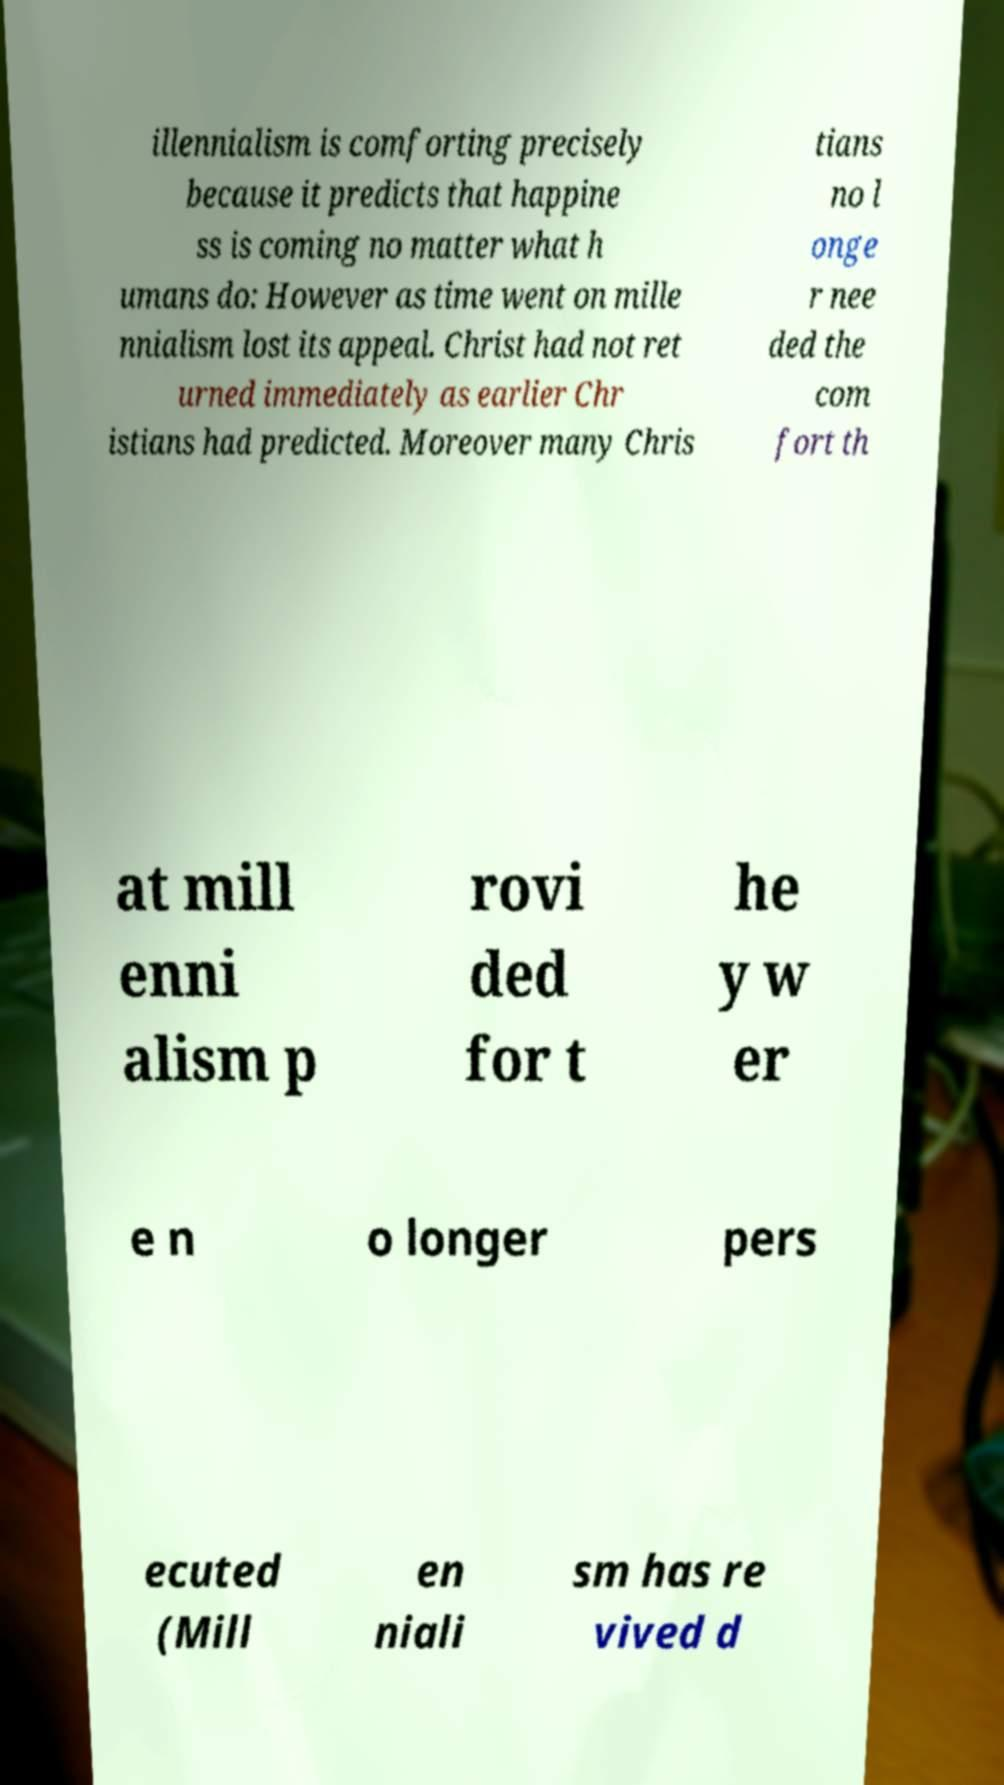Could you assist in decoding the text presented in this image and type it out clearly? illennialism is comforting precisely because it predicts that happine ss is coming no matter what h umans do: However as time went on mille nnialism lost its appeal. Christ had not ret urned immediately as earlier Chr istians had predicted. Moreover many Chris tians no l onge r nee ded the com fort th at mill enni alism p rovi ded for t he y w er e n o longer pers ecuted (Mill en niali sm has re vived d 